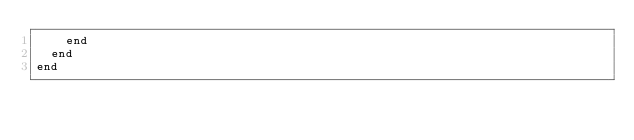Convert code to text. <code><loc_0><loc_0><loc_500><loc_500><_Ruby_>    end
  end
end
</code> 